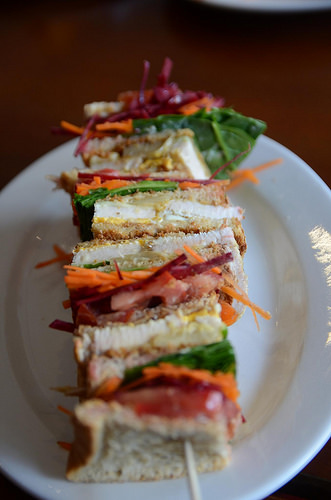<image>
Is the food on the plate? Yes. Looking at the image, I can see the food is positioned on top of the plate, with the plate providing support. 